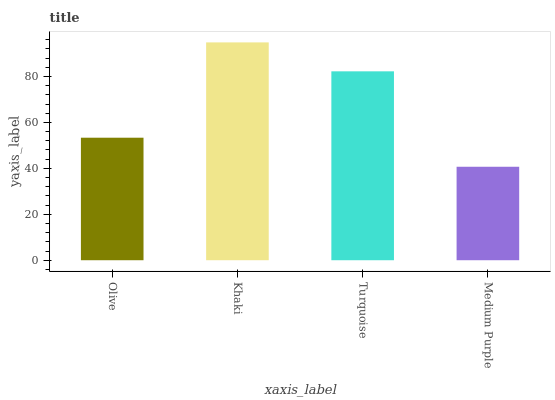Is Medium Purple the minimum?
Answer yes or no. Yes. Is Khaki the maximum?
Answer yes or no. Yes. Is Turquoise the minimum?
Answer yes or no. No. Is Turquoise the maximum?
Answer yes or no. No. Is Khaki greater than Turquoise?
Answer yes or no. Yes. Is Turquoise less than Khaki?
Answer yes or no. Yes. Is Turquoise greater than Khaki?
Answer yes or no. No. Is Khaki less than Turquoise?
Answer yes or no. No. Is Turquoise the high median?
Answer yes or no. Yes. Is Olive the low median?
Answer yes or no. Yes. Is Medium Purple the high median?
Answer yes or no. No. Is Medium Purple the low median?
Answer yes or no. No. 